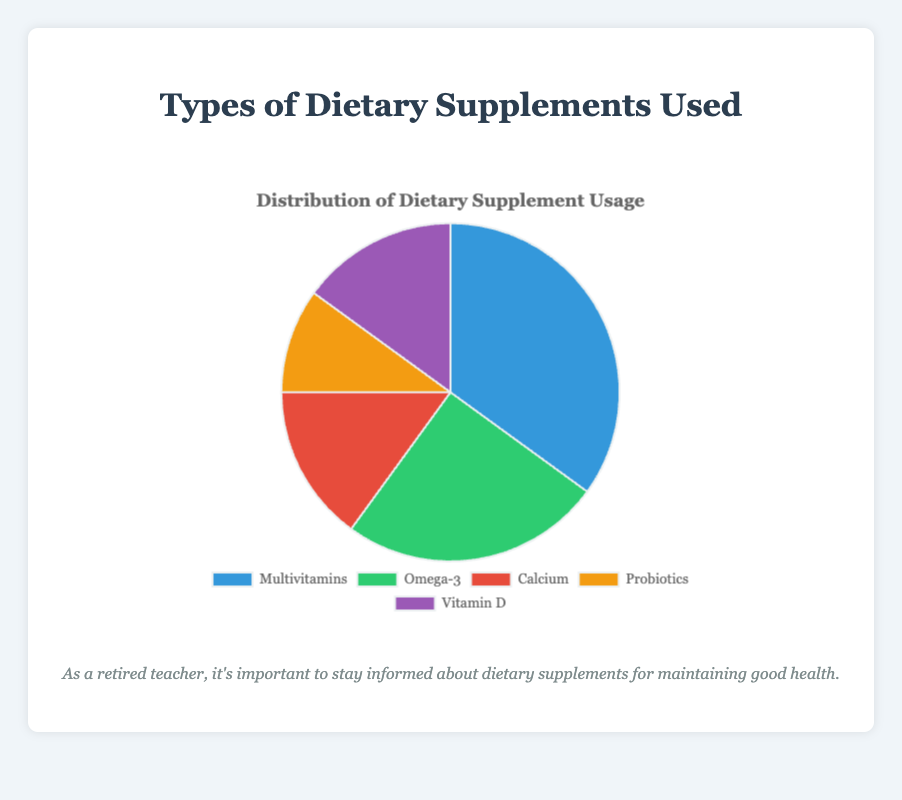What is the percentage of people using Multivitamins? By looking at the "Multivitamins" part in the pie chart, we can see that it occupies 35% of the total.
Answer: 35% Which supplement is used the least, and by what percentage? By looking at the five segments, the smallest segment corresponds to "Probiotics," which occupies 10% of the total.
Answer: Probiotics, 10% What is the total percentage of people using Calcium and Vitamin D combined? From the chart, Calcium is 15% and Vitamin D is 15%. Adding these together, you get 15% + 15% = 30%.
Answer: 30% Which supplement is used more, Omega-3 or Calcium, and by how much? Omega-3 occupies 25% while Calcium occupies 15%. The difference is 25% - 15% = 10%.
Answer: Omega-3, by 10% Which supplement has a usage rate equal to the usage rate of Calcium? By examining the percentages in the chart, Vitamin D also has a usage rate of 15%, the same as Calcium.
Answer: Vitamin D What is the difference in usage percentage between the most used supplement and the least used supplement? The most used supplement is Multivitamins at 35%, and the least used is Probiotics at 10%. The difference is 35% - 10% = 25%.
Answer: 25% Given the colors in the chart, which supplement is represented by the green segment? By referring to the chart, the green segment represents Omega-3, which is 25%.
Answer: Omega-3 What is the average usage percentage of all the supplements combined? Sum up all the percentages: 35% (Multivitamins) + 25% (Omega-3) + 15% (Calcium) + 10% (Probiotics) + 15% (Vitamin D) = 100%. Divide by the number of supplements (5): 100% / 5 = 20%.
Answer: 20% Which supplement has the second-lowest usage rate after Probiotics? By referring to the chart, after Probiotics (10%), both Calcium and Vitamin D have the next lowest usage rate at 15%.
Answer: Calcium and Vitamin D 